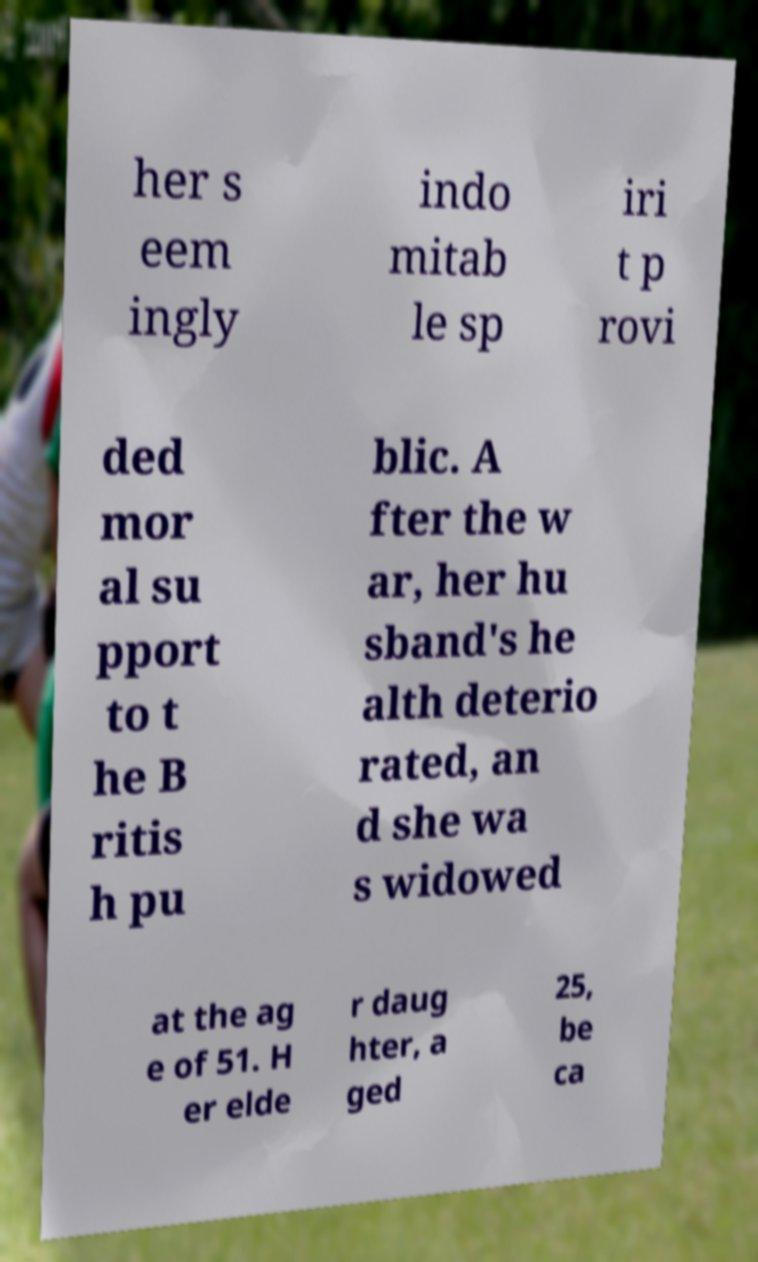For documentation purposes, I need the text within this image transcribed. Could you provide that? her s eem ingly indo mitab le sp iri t p rovi ded mor al su pport to t he B ritis h pu blic. A fter the w ar, her hu sband's he alth deterio rated, an d she wa s widowed at the ag e of 51. H er elde r daug hter, a ged 25, be ca 